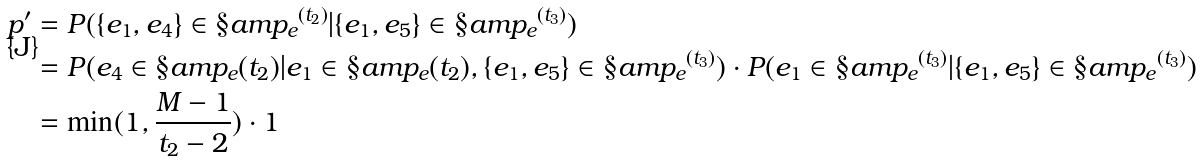Convert formula to latex. <formula><loc_0><loc_0><loc_500><loc_500>p ^ { \prime } & = P ( \{ e _ { 1 } , e _ { 4 } \} \in { \S a m p _ { e } } ^ { ( t _ { 2 } ) } | \{ e _ { 1 } , e _ { 5 } \} \in { \S a m p _ { e } } ^ { ( t _ { 3 } ) } ) \\ & = P ( e _ { 4 } \in \S a m p _ { e } ( t _ { 2 } ) | e _ { 1 } \in \S a m p _ { e } ( t _ { 2 } ) , \{ e _ { 1 } , e _ { 5 } \} \in { \S a m p _ { e } } ^ { ( t _ { 3 } ) } ) \cdot P ( e _ { 1 } \in { \S a m p _ { e } } ^ { ( t _ { 3 } ) } | \{ e _ { 1 } , e _ { 5 } \} \in { \S a m p _ { e } } ^ { ( t _ { 3 } ) } ) \\ & = \min ( 1 , \frac { M - 1 } { t _ { 2 } - 2 } ) \cdot 1</formula> 